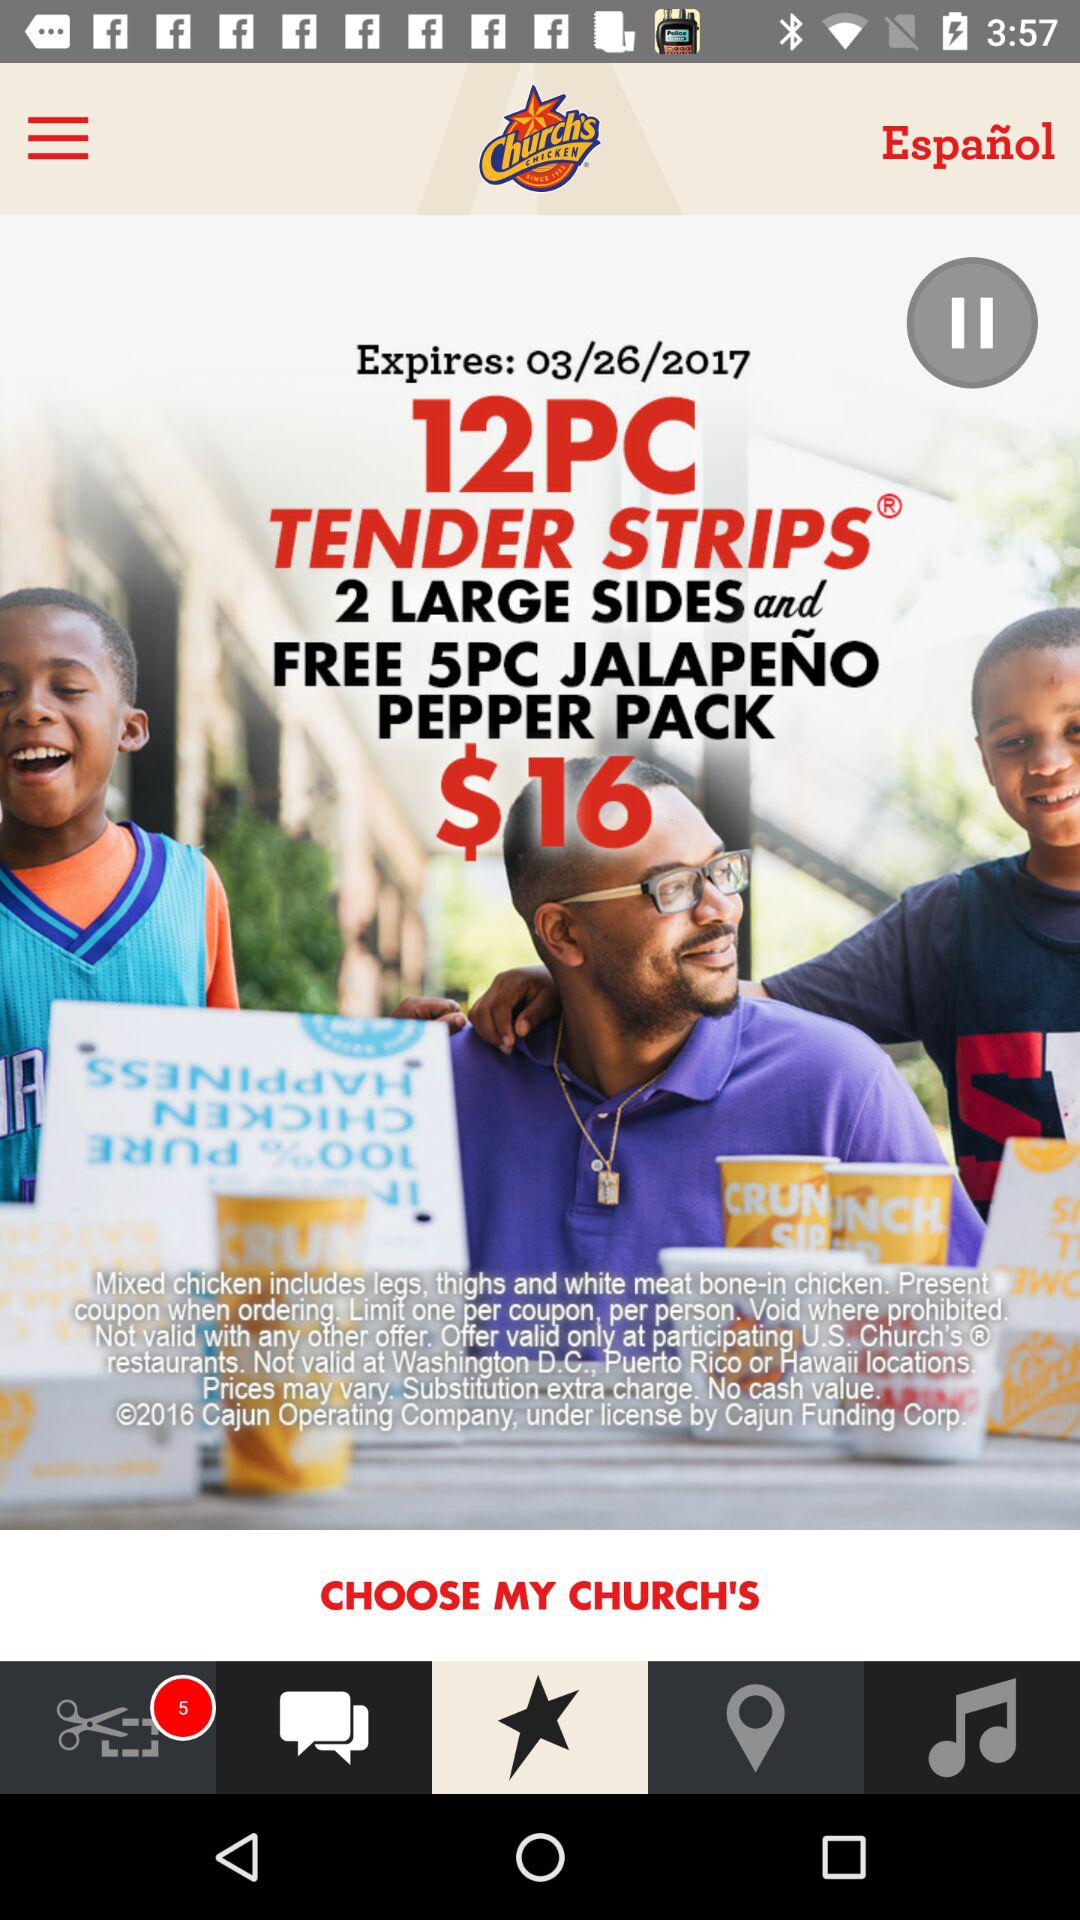What is the number of notifications? The number of notifications is 5. 